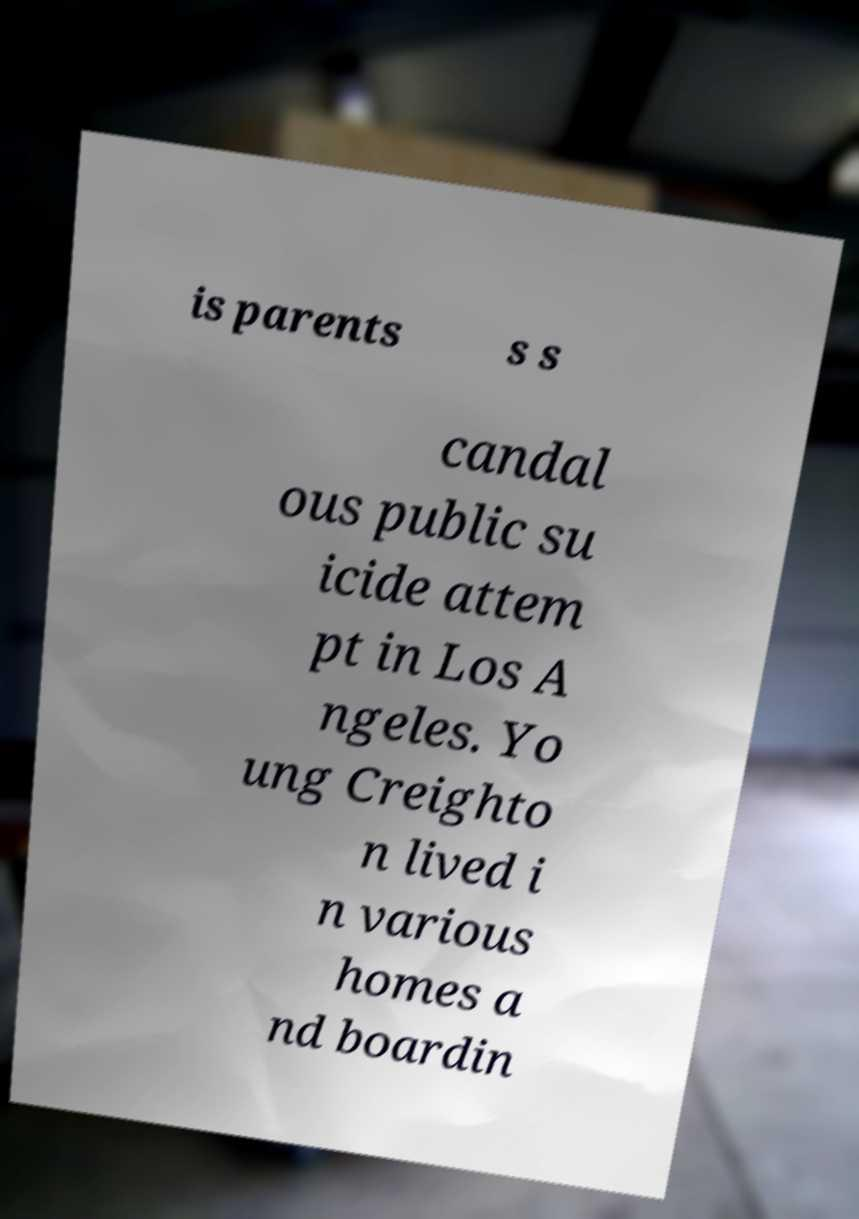Can you accurately transcribe the text from the provided image for me? is parents s s candal ous public su icide attem pt in Los A ngeles. Yo ung Creighto n lived i n various homes a nd boardin 